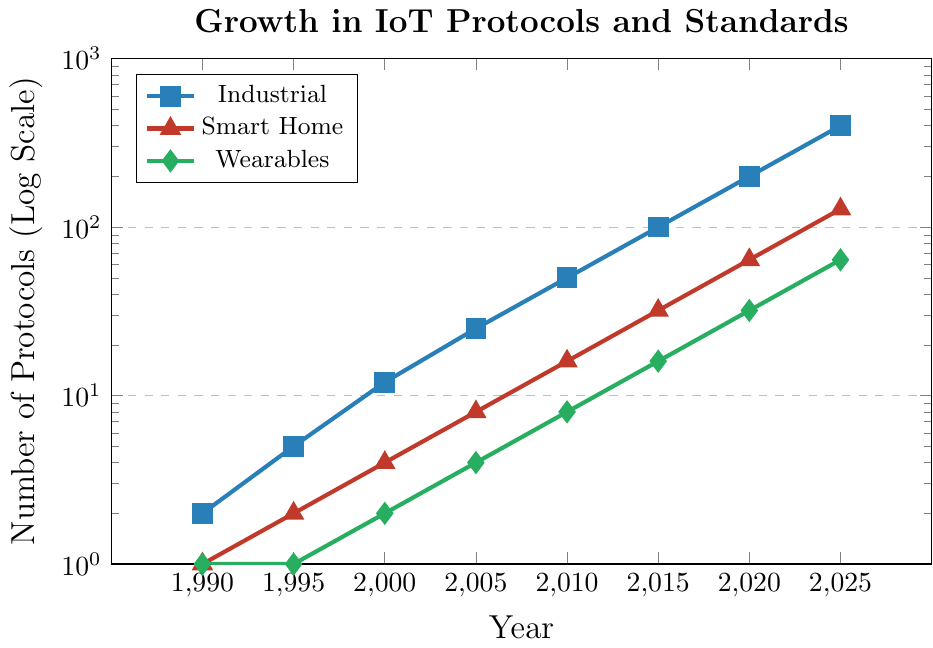What trend can be observed in the number of IoT protocols for the Industrial application between 1990 and 2025? The number of protocols for the Industrial application area shows exponential growth over the years, going from 2 in 1990 to 400 in 2025. This indicates a rapid increase in the development and adoption of protocols in this sector.
Answer: Exponential growth Between which years did Smart Home IoT protocols double from the previous value the most frequently? The data shows that the number of Smart Home protocols doubled approximately every 5 years: from 1 in 1990 to 2 in 1995, 4 in 2000, 8 in 2005, 16 in 2010, 32 in 2015, 64 in 2020, and 128 in 2025. Therefore, doubling occurs most frequently every 5 years.
Answer: Every 5 years For the Wearables application, what is the total increase in the number of protocols from 1990 to 2025? The number of Wearables protocols increases from 1 in 1990 to 64 in 2025. To find the total increase, subtract the initial value from the final value: 64 - 1 = 63.
Answer: 63 Which application area has the highest number of IoT protocols in 2025, and what is the exact number? According to the data, the Industrial application area has the highest number of IoT protocols in 2025, with a total of 400 protocols.
Answer: Industrial, 400 In what way is the Wearables application’s growth pattern similar to or different from the Smart Home application’s growth pattern? Both Wearables and Smart Home applications show exponential growth patterns. However, the Wearables protocols started with a slower growth rate (remaining at 1 from 1990 to 1995) compared to the Smart Home protocols, which doubled from 1 to 2 between the same years. Overall, both doubled nearly every 5 years but started from different bases.
Answer: Similar exponential growth By what factor did the number of Industrial IoT protocols increase from 1990 to 2025? The number of Industrial IoT protocols increased from 2 in 1990 to 400 in 2025. The factor can be calculated as 400 / 2 = 200.
Answer: 200 How do the colors distinguish among the application areas on the plot? The Industrial application is represented by blue, the Smart Home application by red, and the Wearables application by green. This color-coding helps visually differentiate the data trends.
Answer: Blue, Red, Green If the trend continues, how many Smart Home IoT protocols would you expect in 2030? Observing the pattern, the number of Smart Home IoT protocols doubles approximately every 5 years. From 2025 (128 protocols), we expect double in 5 years: 128 * 2 = 256 protocols in 2030.
Answer: 256 When was the first year the number of Industrial IoT protocols reached or exceeded 100? According to the data, the number of Industrial IoT protocols reached 100 in 2015. Before 2015, the number was 50 in 2010.
Answer: 2015 Comparing 2000 and 2020, by what factor did the number of Wearables and Industrial protocols increase? For Wearables, the number increased from 2 in 2000 to 32 in 2020. The factor for Wearables is 32 / 2 = 16. For Industrial, it increased from 12 in 2000 to 200 in 2020. The factor for Industrial is 200 / 12 ≈ 16.67.
Answer: Wearables: 16, Industrial: 16.67 